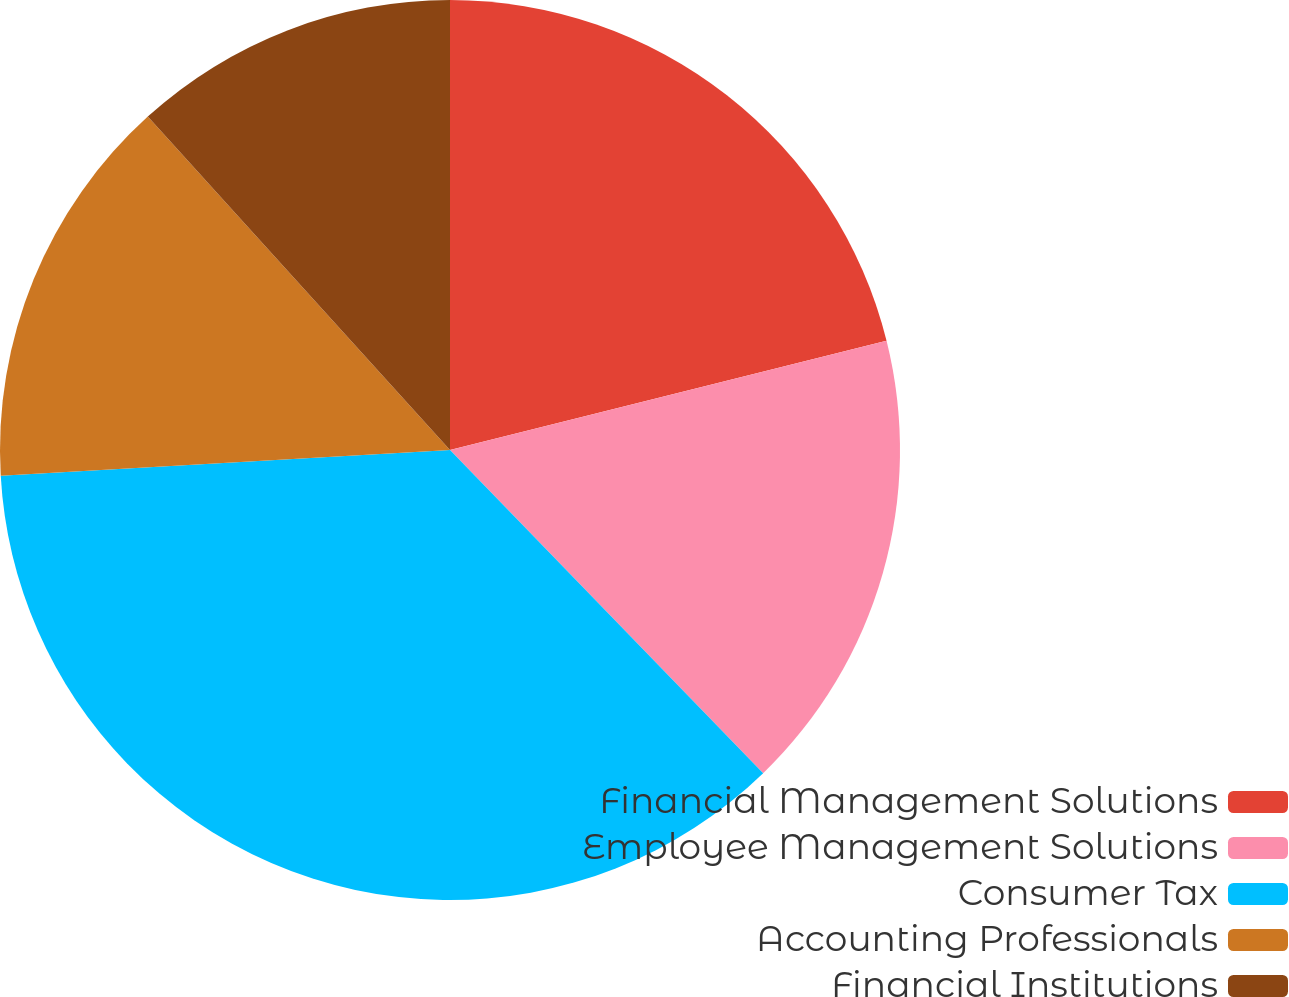<chart> <loc_0><loc_0><loc_500><loc_500><pie_chart><fcel>Financial Management Solutions<fcel>Employee Management Solutions<fcel>Consumer Tax<fcel>Accounting Professionals<fcel>Financial Institutions<nl><fcel>21.1%<fcel>16.65%<fcel>36.34%<fcel>14.19%<fcel>11.72%<nl></chart> 